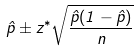Convert formula to latex. <formula><loc_0><loc_0><loc_500><loc_500>\hat { p } \pm z ^ { * } \sqrt { \frac { \hat { p } ( 1 - \hat { p } ) } { n } }</formula> 